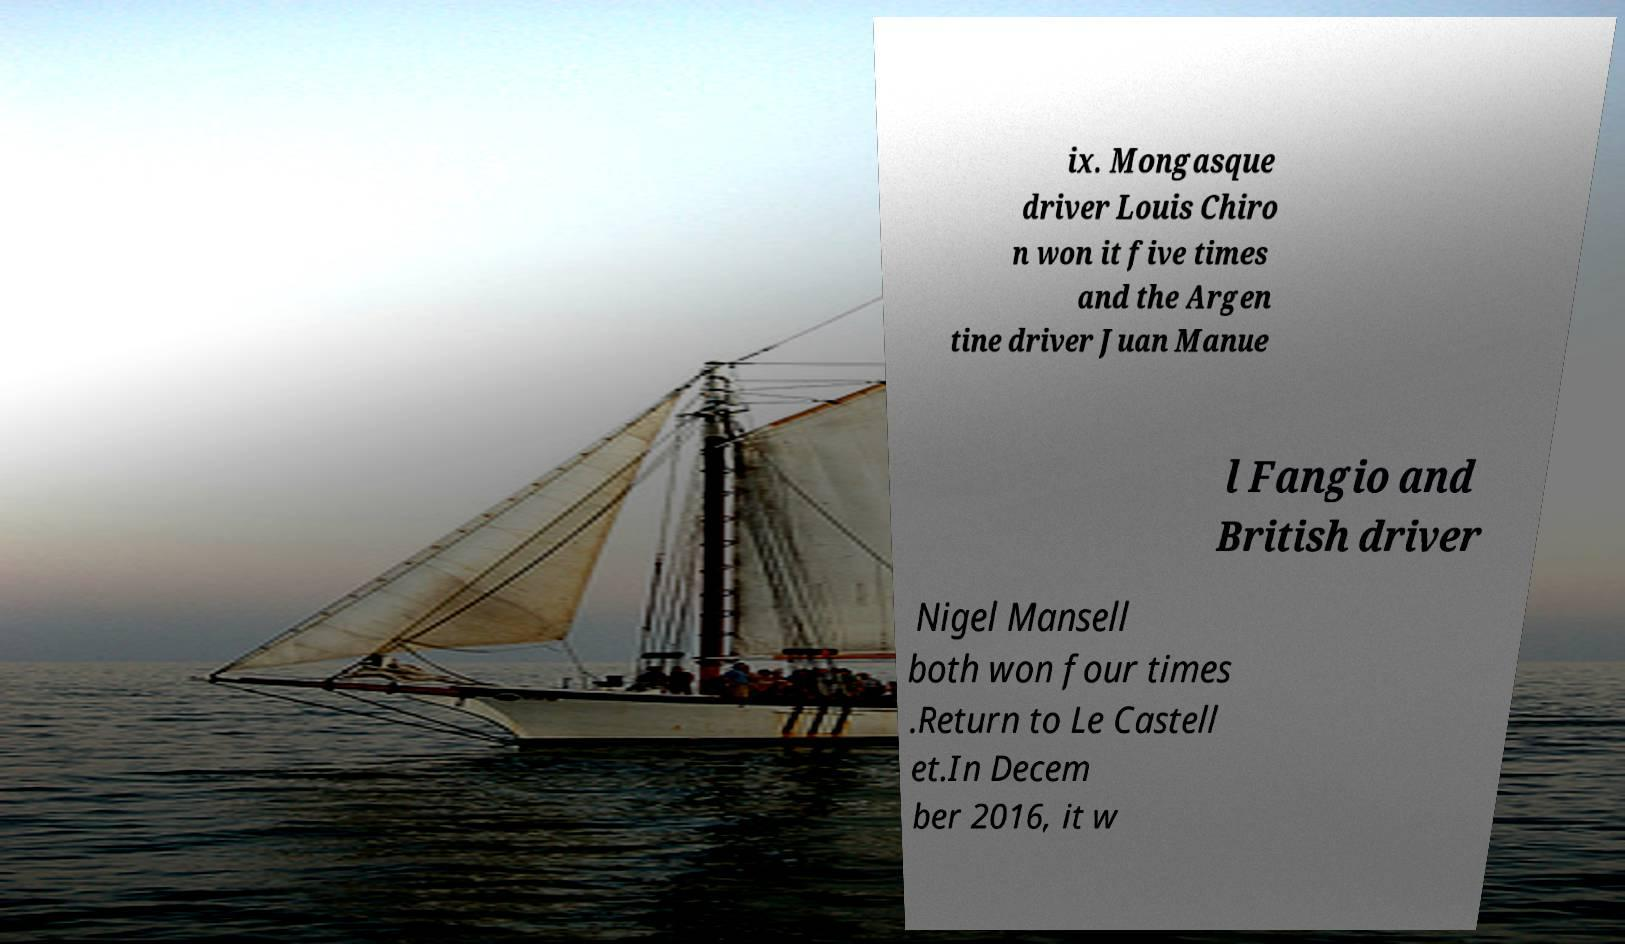Please read and relay the text visible in this image. What does it say? ix. Mongasque driver Louis Chiro n won it five times and the Argen tine driver Juan Manue l Fangio and British driver Nigel Mansell both won four times .Return to Le Castell et.In Decem ber 2016, it w 